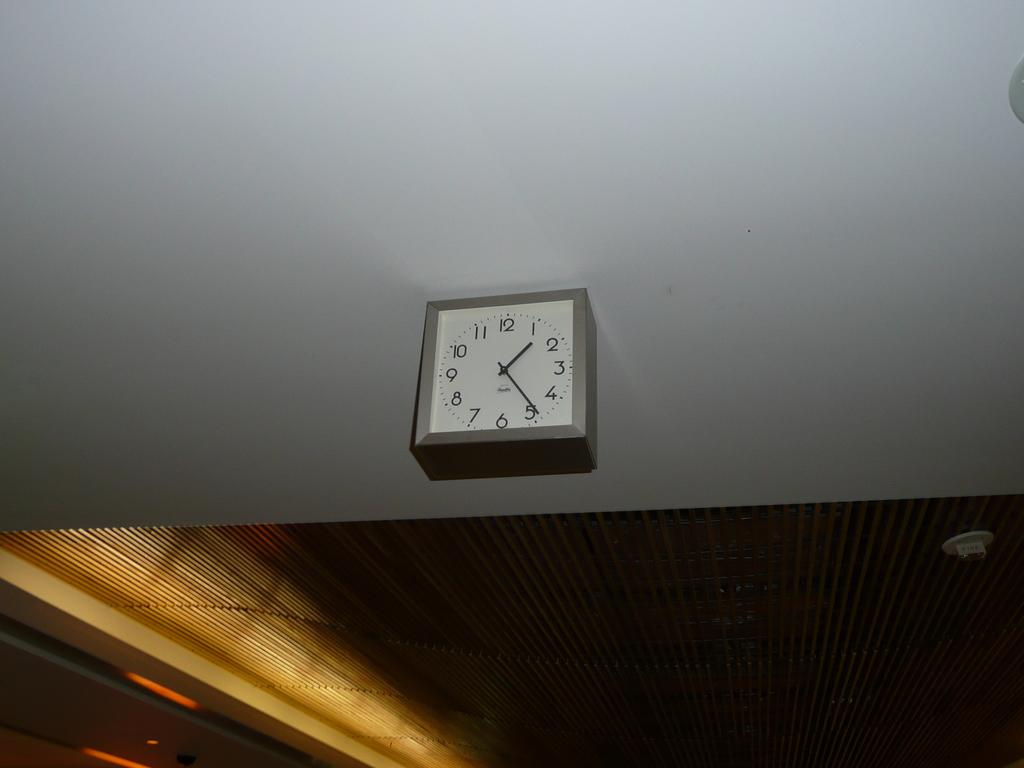Provide a one-sentence caption for the provided image. white clock on the wall with the hands at 1 and 5. 